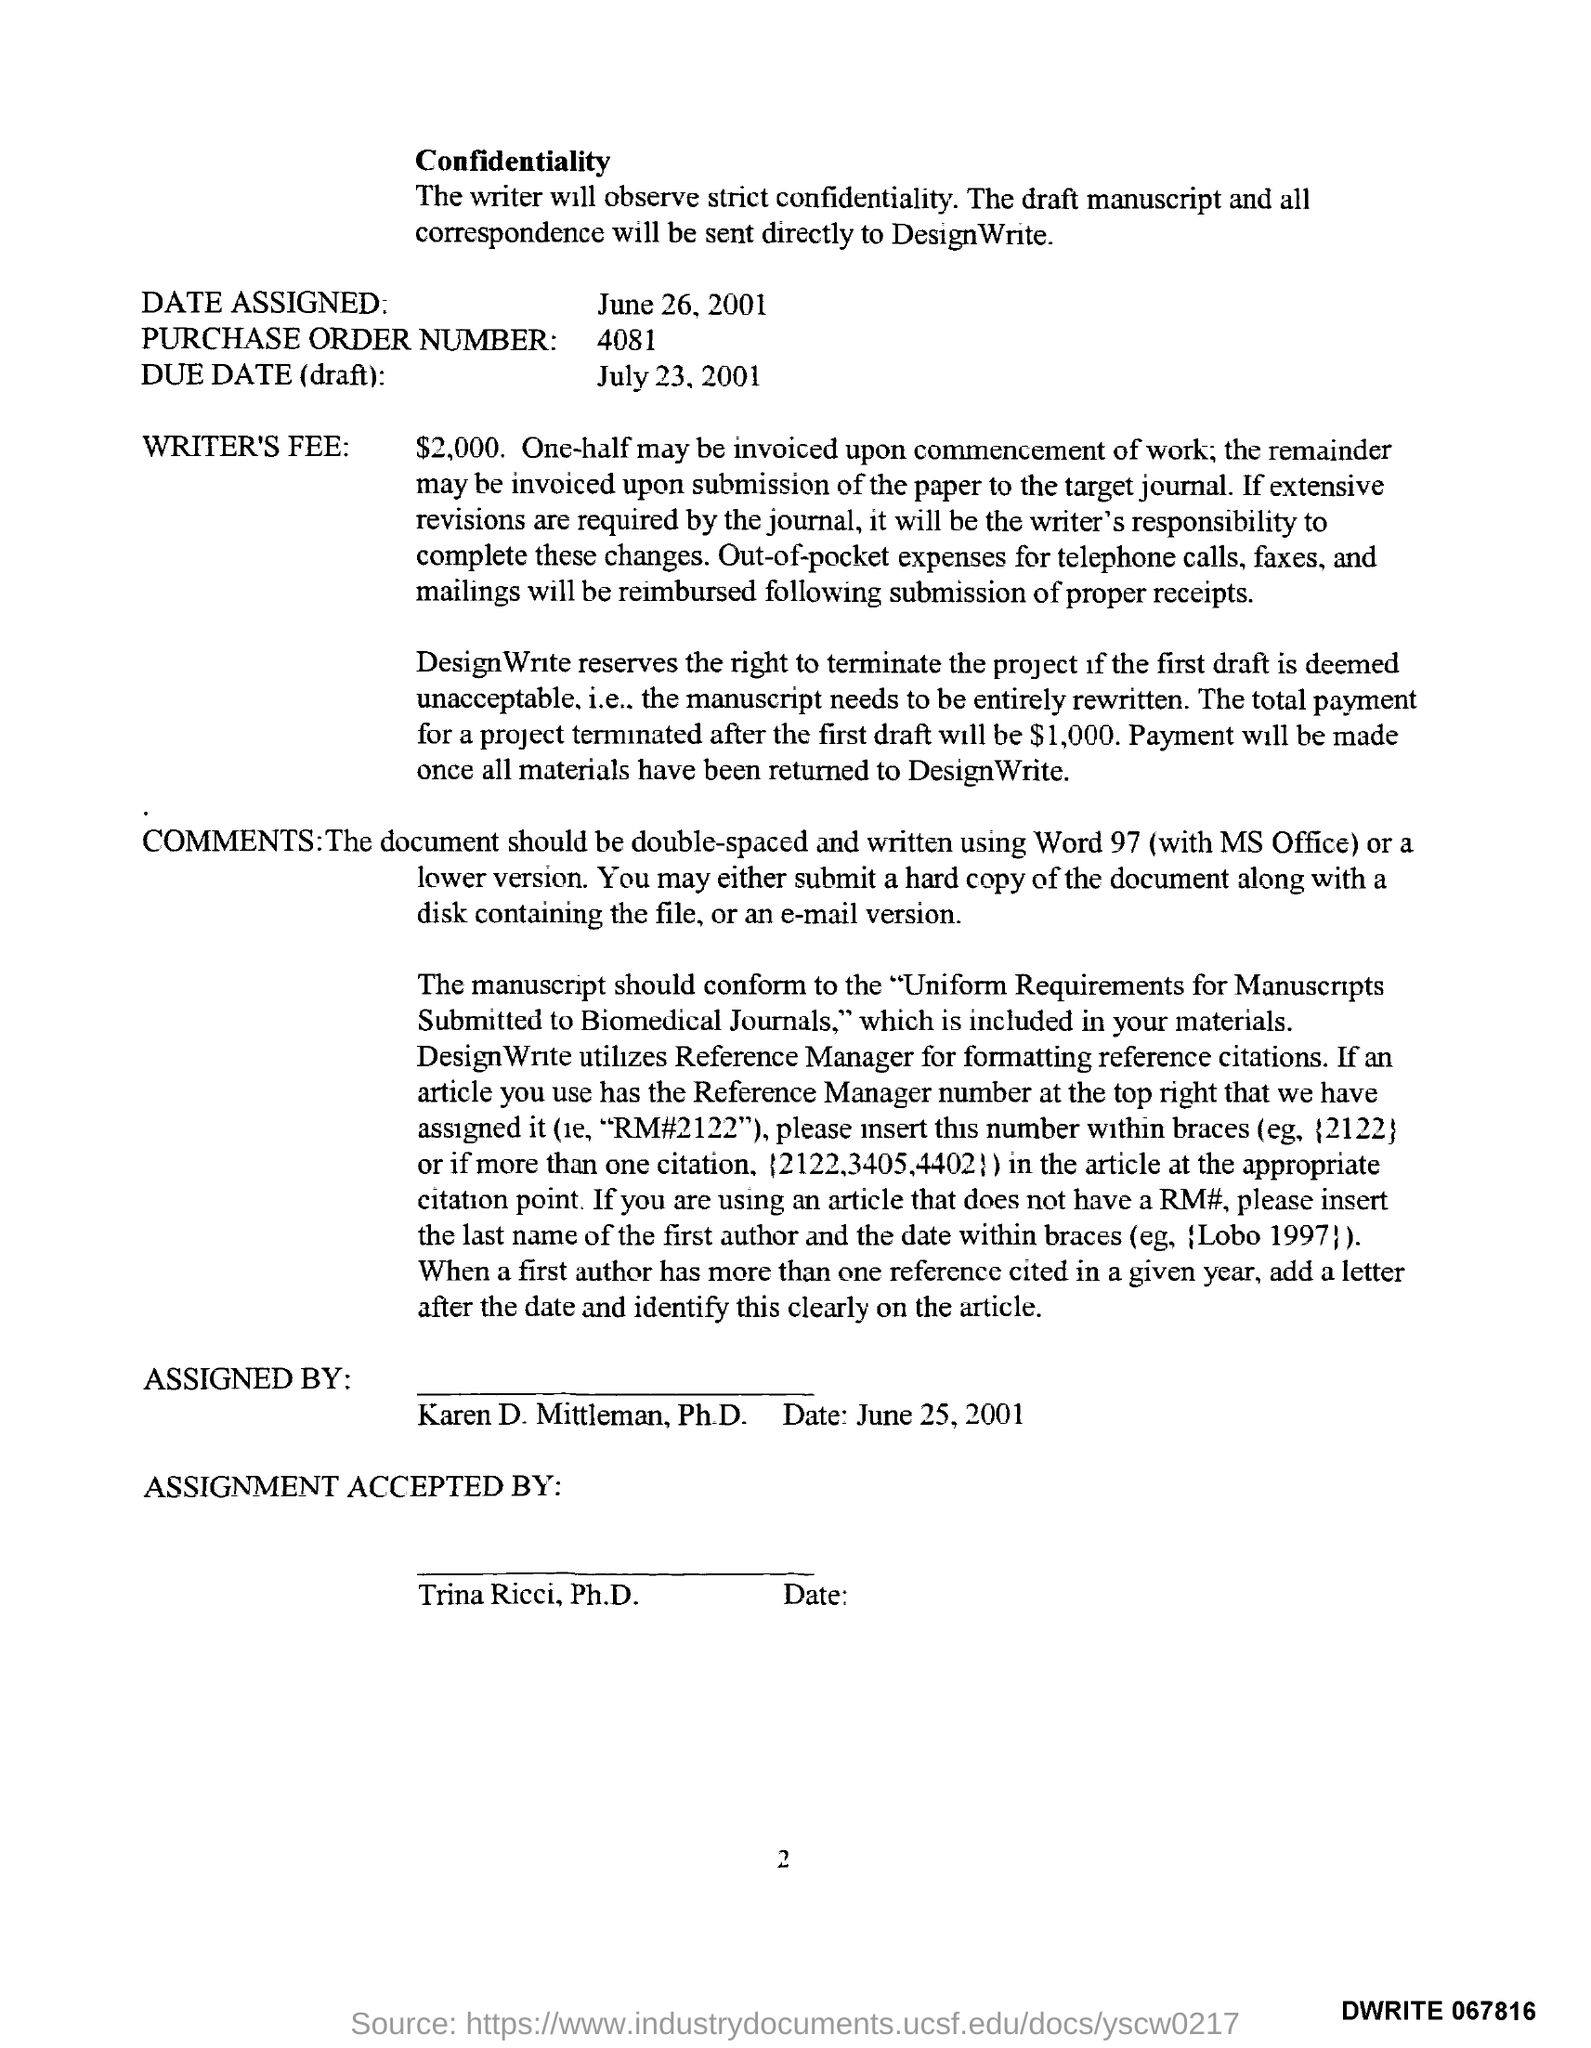What is the Page Number?
Ensure brevity in your answer.  2. What is the purchase order number?
Keep it short and to the point. 4081. What is "date assigned"?
Ensure brevity in your answer.  JUne 26, 2001. Who accepted the assignment?
Ensure brevity in your answer.  Trina Ricci, Ph.D. What is the due date?
Offer a very short reply. July 23,2001. 